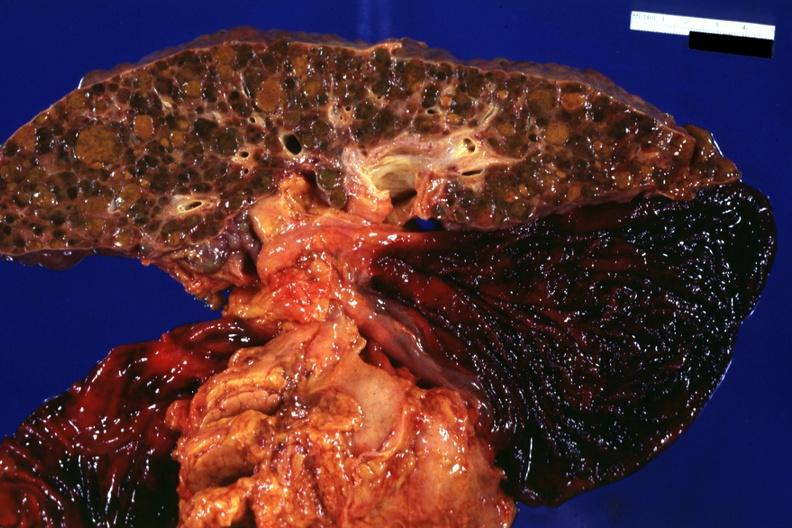s atherosclerosis present?
Answer the question using a single word or phrase. No 